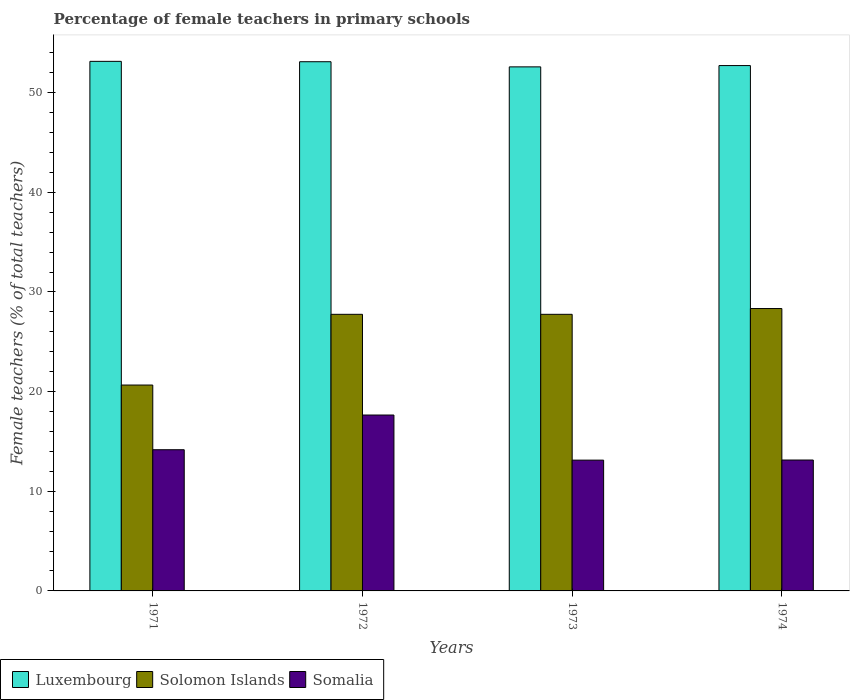Are the number of bars per tick equal to the number of legend labels?
Provide a short and direct response. Yes. How many bars are there on the 3rd tick from the right?
Your answer should be very brief. 3. What is the label of the 2nd group of bars from the left?
Your response must be concise. 1972. What is the percentage of female teachers in Somalia in 1973?
Make the answer very short. 13.13. Across all years, what is the maximum percentage of female teachers in Somalia?
Your answer should be very brief. 17.65. Across all years, what is the minimum percentage of female teachers in Solomon Islands?
Your response must be concise. 20.66. In which year was the percentage of female teachers in Somalia maximum?
Give a very brief answer. 1972. In which year was the percentage of female teachers in Somalia minimum?
Ensure brevity in your answer.  1973. What is the total percentage of female teachers in Somalia in the graph?
Offer a very short reply. 58.08. What is the difference between the percentage of female teachers in Somalia in 1971 and that in 1973?
Your answer should be very brief. 1.04. What is the difference between the percentage of female teachers in Solomon Islands in 1973 and the percentage of female teachers in Luxembourg in 1974?
Ensure brevity in your answer.  -24.96. What is the average percentage of female teachers in Solomon Islands per year?
Offer a terse response. 26.13. In the year 1971, what is the difference between the percentage of female teachers in Solomon Islands and percentage of female teachers in Luxembourg?
Make the answer very short. -32.48. What is the ratio of the percentage of female teachers in Somalia in 1972 to that in 1974?
Give a very brief answer. 1.34. Is the difference between the percentage of female teachers in Solomon Islands in 1972 and 1974 greater than the difference between the percentage of female teachers in Luxembourg in 1972 and 1974?
Offer a terse response. No. What is the difference between the highest and the second highest percentage of female teachers in Luxembourg?
Ensure brevity in your answer.  0.04. What is the difference between the highest and the lowest percentage of female teachers in Somalia?
Make the answer very short. 4.53. In how many years, is the percentage of female teachers in Somalia greater than the average percentage of female teachers in Somalia taken over all years?
Offer a terse response. 1. Is the sum of the percentage of female teachers in Solomon Islands in 1973 and 1974 greater than the maximum percentage of female teachers in Somalia across all years?
Give a very brief answer. Yes. What does the 2nd bar from the left in 1974 represents?
Provide a short and direct response. Solomon Islands. What does the 3rd bar from the right in 1971 represents?
Provide a short and direct response. Luxembourg. Is it the case that in every year, the sum of the percentage of female teachers in Somalia and percentage of female teachers in Solomon Islands is greater than the percentage of female teachers in Luxembourg?
Make the answer very short. No. How many bars are there?
Keep it short and to the point. 12. How many years are there in the graph?
Keep it short and to the point. 4. What is the difference between two consecutive major ticks on the Y-axis?
Give a very brief answer. 10. Are the values on the major ticks of Y-axis written in scientific E-notation?
Keep it short and to the point. No. Does the graph contain any zero values?
Your answer should be compact. No. Does the graph contain grids?
Ensure brevity in your answer.  No. Where does the legend appear in the graph?
Your answer should be very brief. Bottom left. How many legend labels are there?
Your answer should be very brief. 3. What is the title of the graph?
Ensure brevity in your answer.  Percentage of female teachers in primary schools. Does "East Asia (all income levels)" appear as one of the legend labels in the graph?
Offer a terse response. No. What is the label or title of the X-axis?
Give a very brief answer. Years. What is the label or title of the Y-axis?
Your answer should be compact. Female teachers (% of total teachers). What is the Female teachers (% of total teachers) of Luxembourg in 1971?
Ensure brevity in your answer.  53.14. What is the Female teachers (% of total teachers) in Solomon Islands in 1971?
Offer a terse response. 20.66. What is the Female teachers (% of total teachers) in Somalia in 1971?
Your response must be concise. 14.17. What is the Female teachers (% of total teachers) of Luxembourg in 1972?
Give a very brief answer. 53.11. What is the Female teachers (% of total teachers) in Solomon Islands in 1972?
Keep it short and to the point. 27.76. What is the Female teachers (% of total teachers) of Somalia in 1972?
Ensure brevity in your answer.  17.65. What is the Female teachers (% of total teachers) in Luxembourg in 1973?
Your response must be concise. 52.59. What is the Female teachers (% of total teachers) of Solomon Islands in 1973?
Your answer should be compact. 27.76. What is the Female teachers (% of total teachers) of Somalia in 1973?
Your answer should be very brief. 13.13. What is the Female teachers (% of total teachers) in Luxembourg in 1974?
Provide a short and direct response. 52.72. What is the Female teachers (% of total teachers) in Solomon Islands in 1974?
Provide a succinct answer. 28.34. What is the Female teachers (% of total teachers) of Somalia in 1974?
Your answer should be very brief. 13.14. Across all years, what is the maximum Female teachers (% of total teachers) of Luxembourg?
Give a very brief answer. 53.14. Across all years, what is the maximum Female teachers (% of total teachers) in Solomon Islands?
Your response must be concise. 28.34. Across all years, what is the maximum Female teachers (% of total teachers) of Somalia?
Provide a short and direct response. 17.65. Across all years, what is the minimum Female teachers (% of total teachers) of Luxembourg?
Provide a succinct answer. 52.59. Across all years, what is the minimum Female teachers (% of total teachers) of Solomon Islands?
Your answer should be compact. 20.66. Across all years, what is the minimum Female teachers (% of total teachers) in Somalia?
Your answer should be compact. 13.13. What is the total Female teachers (% of total teachers) of Luxembourg in the graph?
Offer a terse response. 211.56. What is the total Female teachers (% of total teachers) in Solomon Islands in the graph?
Provide a succinct answer. 104.51. What is the total Female teachers (% of total teachers) in Somalia in the graph?
Give a very brief answer. 58.08. What is the difference between the Female teachers (% of total teachers) of Luxembourg in 1971 and that in 1972?
Your answer should be compact. 0.04. What is the difference between the Female teachers (% of total teachers) in Solomon Islands in 1971 and that in 1972?
Ensure brevity in your answer.  -7.1. What is the difference between the Female teachers (% of total teachers) of Somalia in 1971 and that in 1972?
Give a very brief answer. -3.48. What is the difference between the Female teachers (% of total teachers) in Luxembourg in 1971 and that in 1973?
Provide a succinct answer. 0.55. What is the difference between the Female teachers (% of total teachers) of Solomon Islands in 1971 and that in 1973?
Provide a short and direct response. -7.1. What is the difference between the Female teachers (% of total teachers) in Somalia in 1971 and that in 1973?
Give a very brief answer. 1.04. What is the difference between the Female teachers (% of total teachers) in Luxembourg in 1971 and that in 1974?
Ensure brevity in your answer.  0.42. What is the difference between the Female teachers (% of total teachers) of Solomon Islands in 1971 and that in 1974?
Your answer should be very brief. -7.68. What is the difference between the Female teachers (% of total teachers) in Somalia in 1971 and that in 1974?
Your answer should be compact. 1.03. What is the difference between the Female teachers (% of total teachers) in Luxembourg in 1972 and that in 1973?
Provide a succinct answer. 0.52. What is the difference between the Female teachers (% of total teachers) of Somalia in 1972 and that in 1973?
Ensure brevity in your answer.  4.53. What is the difference between the Female teachers (% of total teachers) in Luxembourg in 1972 and that in 1974?
Keep it short and to the point. 0.39. What is the difference between the Female teachers (% of total teachers) in Solomon Islands in 1972 and that in 1974?
Give a very brief answer. -0.58. What is the difference between the Female teachers (% of total teachers) in Somalia in 1972 and that in 1974?
Provide a short and direct response. 4.52. What is the difference between the Female teachers (% of total teachers) of Luxembourg in 1973 and that in 1974?
Make the answer very short. -0.13. What is the difference between the Female teachers (% of total teachers) in Solomon Islands in 1973 and that in 1974?
Provide a succinct answer. -0.58. What is the difference between the Female teachers (% of total teachers) in Somalia in 1973 and that in 1974?
Give a very brief answer. -0.01. What is the difference between the Female teachers (% of total teachers) in Luxembourg in 1971 and the Female teachers (% of total teachers) in Solomon Islands in 1972?
Keep it short and to the point. 25.39. What is the difference between the Female teachers (% of total teachers) of Luxembourg in 1971 and the Female teachers (% of total teachers) of Somalia in 1972?
Your response must be concise. 35.49. What is the difference between the Female teachers (% of total teachers) in Solomon Islands in 1971 and the Female teachers (% of total teachers) in Somalia in 1972?
Your answer should be compact. 3.01. What is the difference between the Female teachers (% of total teachers) in Luxembourg in 1971 and the Female teachers (% of total teachers) in Solomon Islands in 1973?
Your answer should be compact. 25.39. What is the difference between the Female teachers (% of total teachers) in Luxembourg in 1971 and the Female teachers (% of total teachers) in Somalia in 1973?
Offer a very short reply. 40.02. What is the difference between the Female teachers (% of total teachers) in Solomon Islands in 1971 and the Female teachers (% of total teachers) in Somalia in 1973?
Your response must be concise. 7.54. What is the difference between the Female teachers (% of total teachers) in Luxembourg in 1971 and the Female teachers (% of total teachers) in Solomon Islands in 1974?
Keep it short and to the point. 24.81. What is the difference between the Female teachers (% of total teachers) in Luxembourg in 1971 and the Female teachers (% of total teachers) in Somalia in 1974?
Your answer should be compact. 40.01. What is the difference between the Female teachers (% of total teachers) in Solomon Islands in 1971 and the Female teachers (% of total teachers) in Somalia in 1974?
Offer a very short reply. 7.52. What is the difference between the Female teachers (% of total teachers) of Luxembourg in 1972 and the Female teachers (% of total teachers) of Solomon Islands in 1973?
Provide a succinct answer. 25.35. What is the difference between the Female teachers (% of total teachers) of Luxembourg in 1972 and the Female teachers (% of total teachers) of Somalia in 1973?
Make the answer very short. 39.98. What is the difference between the Female teachers (% of total teachers) in Solomon Islands in 1972 and the Female teachers (% of total teachers) in Somalia in 1973?
Give a very brief answer. 14.63. What is the difference between the Female teachers (% of total teachers) of Luxembourg in 1972 and the Female teachers (% of total teachers) of Solomon Islands in 1974?
Offer a very short reply. 24.77. What is the difference between the Female teachers (% of total teachers) in Luxembourg in 1972 and the Female teachers (% of total teachers) in Somalia in 1974?
Your answer should be very brief. 39.97. What is the difference between the Female teachers (% of total teachers) in Solomon Islands in 1972 and the Female teachers (% of total teachers) in Somalia in 1974?
Ensure brevity in your answer.  14.62. What is the difference between the Female teachers (% of total teachers) of Luxembourg in 1973 and the Female teachers (% of total teachers) of Solomon Islands in 1974?
Provide a succinct answer. 24.25. What is the difference between the Female teachers (% of total teachers) of Luxembourg in 1973 and the Female teachers (% of total teachers) of Somalia in 1974?
Provide a short and direct response. 39.45. What is the difference between the Female teachers (% of total teachers) of Solomon Islands in 1973 and the Female teachers (% of total teachers) of Somalia in 1974?
Your response must be concise. 14.62. What is the average Female teachers (% of total teachers) of Luxembourg per year?
Your answer should be compact. 52.89. What is the average Female teachers (% of total teachers) of Solomon Islands per year?
Give a very brief answer. 26.13. What is the average Female teachers (% of total teachers) in Somalia per year?
Provide a short and direct response. 14.52. In the year 1971, what is the difference between the Female teachers (% of total teachers) of Luxembourg and Female teachers (% of total teachers) of Solomon Islands?
Keep it short and to the point. 32.48. In the year 1971, what is the difference between the Female teachers (% of total teachers) in Luxembourg and Female teachers (% of total teachers) in Somalia?
Make the answer very short. 38.97. In the year 1971, what is the difference between the Female teachers (% of total teachers) in Solomon Islands and Female teachers (% of total teachers) in Somalia?
Your answer should be very brief. 6.49. In the year 1972, what is the difference between the Female teachers (% of total teachers) of Luxembourg and Female teachers (% of total teachers) of Solomon Islands?
Keep it short and to the point. 25.35. In the year 1972, what is the difference between the Female teachers (% of total teachers) in Luxembourg and Female teachers (% of total teachers) in Somalia?
Ensure brevity in your answer.  35.45. In the year 1972, what is the difference between the Female teachers (% of total teachers) of Solomon Islands and Female teachers (% of total teachers) of Somalia?
Keep it short and to the point. 10.11. In the year 1973, what is the difference between the Female teachers (% of total teachers) in Luxembourg and Female teachers (% of total teachers) in Solomon Islands?
Your answer should be very brief. 24.83. In the year 1973, what is the difference between the Female teachers (% of total teachers) of Luxembourg and Female teachers (% of total teachers) of Somalia?
Offer a terse response. 39.46. In the year 1973, what is the difference between the Female teachers (% of total teachers) of Solomon Islands and Female teachers (% of total teachers) of Somalia?
Ensure brevity in your answer.  14.63. In the year 1974, what is the difference between the Female teachers (% of total teachers) in Luxembourg and Female teachers (% of total teachers) in Solomon Islands?
Your answer should be very brief. 24.38. In the year 1974, what is the difference between the Female teachers (% of total teachers) in Luxembourg and Female teachers (% of total teachers) in Somalia?
Offer a terse response. 39.58. In the year 1974, what is the difference between the Female teachers (% of total teachers) in Solomon Islands and Female teachers (% of total teachers) in Somalia?
Ensure brevity in your answer.  15.2. What is the ratio of the Female teachers (% of total teachers) of Luxembourg in 1971 to that in 1972?
Ensure brevity in your answer.  1. What is the ratio of the Female teachers (% of total teachers) in Solomon Islands in 1971 to that in 1972?
Keep it short and to the point. 0.74. What is the ratio of the Female teachers (% of total teachers) of Somalia in 1971 to that in 1972?
Your answer should be compact. 0.8. What is the ratio of the Female teachers (% of total teachers) of Luxembourg in 1971 to that in 1973?
Give a very brief answer. 1.01. What is the ratio of the Female teachers (% of total teachers) in Solomon Islands in 1971 to that in 1973?
Give a very brief answer. 0.74. What is the ratio of the Female teachers (% of total teachers) of Somalia in 1971 to that in 1973?
Your response must be concise. 1.08. What is the ratio of the Female teachers (% of total teachers) of Solomon Islands in 1971 to that in 1974?
Your answer should be very brief. 0.73. What is the ratio of the Female teachers (% of total teachers) in Somalia in 1971 to that in 1974?
Ensure brevity in your answer.  1.08. What is the ratio of the Female teachers (% of total teachers) of Luxembourg in 1972 to that in 1973?
Your response must be concise. 1.01. What is the ratio of the Female teachers (% of total teachers) in Solomon Islands in 1972 to that in 1973?
Your response must be concise. 1. What is the ratio of the Female teachers (% of total teachers) in Somalia in 1972 to that in 1973?
Your answer should be compact. 1.34. What is the ratio of the Female teachers (% of total teachers) in Luxembourg in 1972 to that in 1974?
Your answer should be compact. 1.01. What is the ratio of the Female teachers (% of total teachers) of Solomon Islands in 1972 to that in 1974?
Ensure brevity in your answer.  0.98. What is the ratio of the Female teachers (% of total teachers) in Somalia in 1972 to that in 1974?
Ensure brevity in your answer.  1.34. What is the ratio of the Female teachers (% of total teachers) of Luxembourg in 1973 to that in 1974?
Your answer should be very brief. 1. What is the ratio of the Female teachers (% of total teachers) in Solomon Islands in 1973 to that in 1974?
Give a very brief answer. 0.98. What is the ratio of the Female teachers (% of total teachers) of Somalia in 1973 to that in 1974?
Your answer should be compact. 1. What is the difference between the highest and the second highest Female teachers (% of total teachers) of Luxembourg?
Ensure brevity in your answer.  0.04. What is the difference between the highest and the second highest Female teachers (% of total teachers) in Solomon Islands?
Offer a terse response. 0.58. What is the difference between the highest and the second highest Female teachers (% of total teachers) in Somalia?
Your response must be concise. 3.48. What is the difference between the highest and the lowest Female teachers (% of total teachers) in Luxembourg?
Give a very brief answer. 0.55. What is the difference between the highest and the lowest Female teachers (% of total teachers) in Solomon Islands?
Provide a short and direct response. 7.68. What is the difference between the highest and the lowest Female teachers (% of total teachers) of Somalia?
Ensure brevity in your answer.  4.53. 